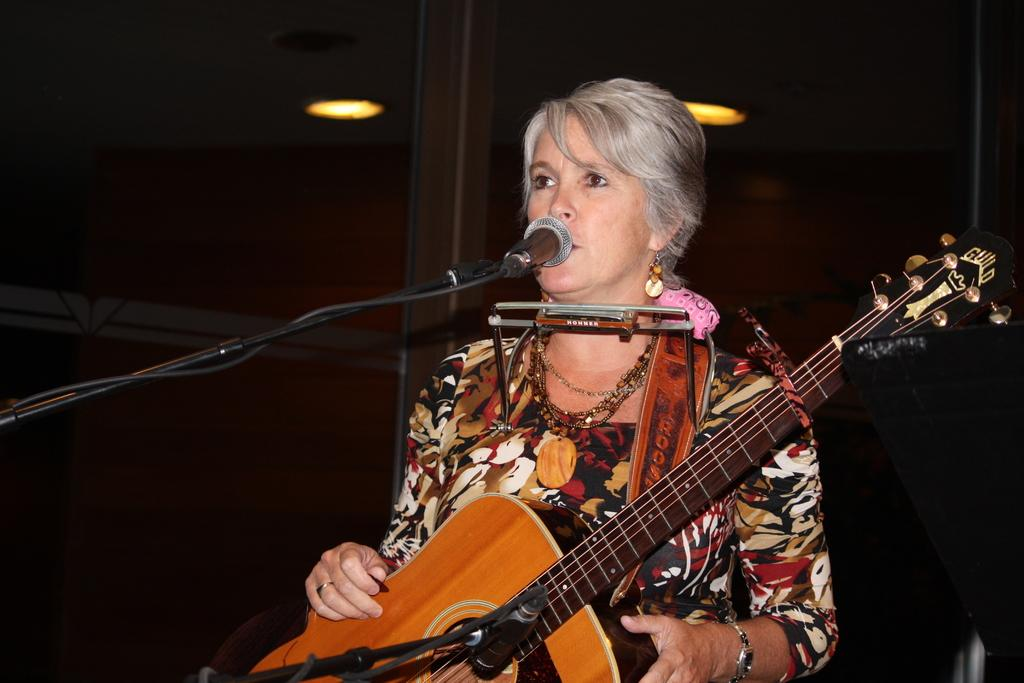Who is the main subject in the image? There is a woman in the image. What is the woman doing in the image? The woman is standing and singing. What object is the woman holding in the image? The woman is holding a guitar. What device is present for amplifying her voice? There is a microphone in the image. What type of engine can be seen powering the guitar in the image? There is no engine present in the image, and the guitar is not powered by an engine. 